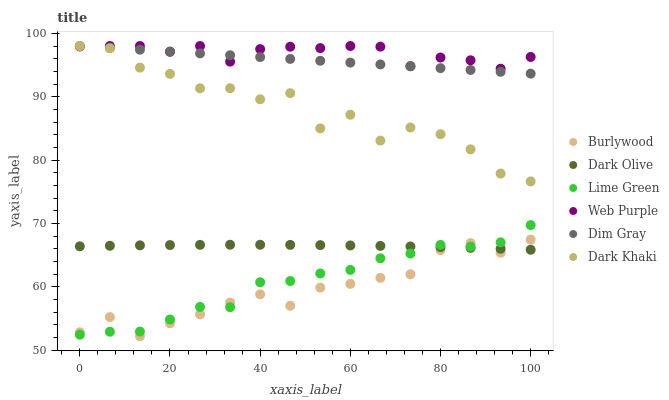Does Burlywood have the minimum area under the curve?
Answer yes or no. Yes. Does Web Purple have the maximum area under the curve?
Answer yes or no. Yes. Does Dark Olive have the minimum area under the curve?
Answer yes or no. No. Does Dark Olive have the maximum area under the curve?
Answer yes or no. No. Is Dim Gray the smoothest?
Answer yes or no. Yes. Is Dark Khaki the roughest?
Answer yes or no. Yes. Is Burlywood the smoothest?
Answer yes or no. No. Is Burlywood the roughest?
Answer yes or no. No. Does Burlywood have the lowest value?
Answer yes or no. Yes. Does Dark Olive have the lowest value?
Answer yes or no. No. Does Web Purple have the highest value?
Answer yes or no. Yes. Does Burlywood have the highest value?
Answer yes or no. No. Is Lime Green less than Web Purple?
Answer yes or no. Yes. Is Dim Gray greater than Dark Olive?
Answer yes or no. Yes. Does Dark Khaki intersect Web Purple?
Answer yes or no. Yes. Is Dark Khaki less than Web Purple?
Answer yes or no. No. Is Dark Khaki greater than Web Purple?
Answer yes or no. No. Does Lime Green intersect Web Purple?
Answer yes or no. No. 